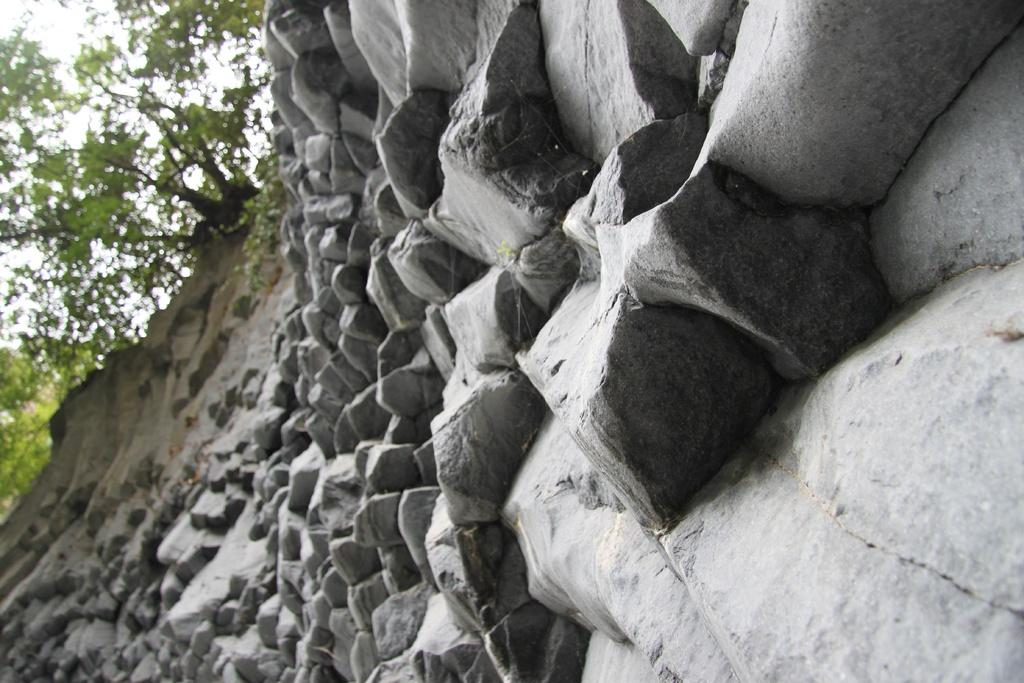What type of natural elements can be seen in the image? There are rocks, stones, and trees in the image. What part of the natural environment is visible in the image? The sky is visible in the image. What type of plantation can be seen in the image? There is no plantation present in the image; it features rocks, stones, trees, and the sky. What is the partner doing in the image? There is no partner present in the image, as it only contains natural elements. 